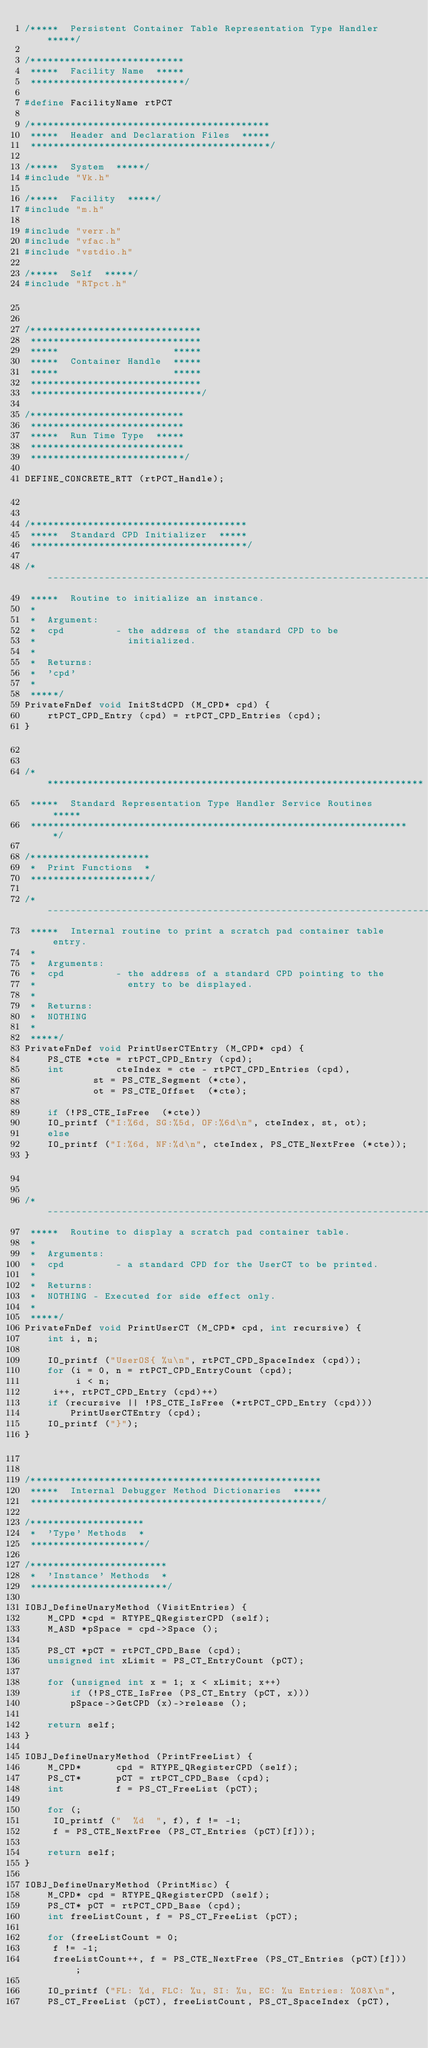<code> <loc_0><loc_0><loc_500><loc_500><_C++_>/*****  Persistent Container Table Representation Type Handler  *****/

/***************************
 *****  Facility Name  *****
 ***************************/

#define FacilityName rtPCT

/******************************************
 *****  Header and Declaration Files  *****
 ******************************************/

/*****  System  *****/
#include "Vk.h"

/*****  Facility  *****/
#include "m.h"

#include "verr.h"
#include "vfac.h"
#include "vstdio.h"

/*****  Self  *****/
#include "RTpct.h"


/******************************
 ******************************
 *****                    *****
 *****  Container Handle  *****
 *****                    *****
 ******************************
 ******************************/

/***************************
 ***************************
 *****  Run Time Type  *****
 ***************************
 ***************************/

DEFINE_CONCRETE_RTT (rtPCT_Handle);


/**************************************
 *****  Standard CPD Initializer  *****
 **************************************/

/*---------------------------------------------------------------------------
 *****  Routine to initialize an instance.
 *
 *  Argument:
 *	cpd			- the address of the standard CPD to be
 *				  initialized.
 *
 *  Returns:
 *	'cpd'
 *
 *****/
PrivateFnDef void InitStdCPD (M_CPD* cpd) {
    rtPCT_CPD_Entry (cpd) = rtPCT_CPD_Entries (cpd);
}


/*******************************************************************
 *****  Standard Representation Type Handler Service Routines  *****
 *******************************************************************/

/*********************
 *  Print Functions  *
 *********************/

/*---------------------------------------------------------------------------
 *****  Internal routine to print a scratch pad container table entry.
 *
 *  Arguments:
 *	cpd			- the address of a standard CPD pointing to the
 *				  entry to be displayed.
 *
 *  Returns:
 *	NOTHING
 *
 *****/
PrivateFnDef void PrintUserCTEntry (M_CPD* cpd) {
    PS_CTE *cte = rtPCT_CPD_Entry (cpd);
    int			cteIndex = cte - rtPCT_CPD_Entries (cpd),
			st = PS_CTE_Segment (*cte),
			ot = PS_CTE_Offset  (*cte);

    if (!PS_CTE_IsFree  (*cte))
	IO_printf ("I:%6d, SG:%5d, OF:%6d\n", cteIndex, st, ot);
    else
	IO_printf ("I:%6d, NF:%d\n", cteIndex, PS_CTE_NextFree (*cte));
}


/*---------------------------------------------------------------------------
 *****  Routine to display a scratch pad container table.
 *
 *  Arguments:
 *	cpd			- a standard CPD for the UserCT to be printed.
 *
 *  Returns:
 *	NOTHING - Executed for side effect only.
 *
 *****/
PrivateFnDef void PrintUserCT (M_CPD* cpd, int recursive) {
    int	i, n;

    IO_printf ("UserOS{ %u\n", rtPCT_CPD_SpaceIndex (cpd));
    for (i = 0, n = rtPCT_CPD_EntryCount (cpd);
    	 i < n;
	 i++, rtPCT_CPD_Entry (cpd)++)
	if (recursive || !PS_CTE_IsFree (*rtPCT_CPD_Entry (cpd)))
	    PrintUserCTEntry (cpd);
    IO_printf ("}");
}


/***************************************************
 *****  Internal Debugger Method Dictionaries  *****
 ***************************************************/

/********************
 *  'Type' Methods  *
 ********************/

/************************
 *  'Instance' Methods  *
 ************************/

IOBJ_DefineUnaryMethod (VisitEntries) {
    M_CPD *cpd = RTYPE_QRegisterCPD (self);
    M_ASD *pSpace = cpd->Space ();

    PS_CT *pCT = rtPCT_CPD_Base (cpd);
    unsigned int xLimit = PS_CT_EntryCount (pCT);

    for (unsigned int x = 1; x < xLimit; x++)
        if (!PS_CTE_IsFree (PS_CT_Entry (pCT, x)))
	    pSpace->GetCPD (x)->release ();

    return self;
}

IOBJ_DefineUnaryMethod (PrintFreeList) {
    M_CPD*		cpd = RTYPE_QRegisterCPD (self);
    PS_CT*		pCT = rtPCT_CPD_Base (cpd);
    int			f = PS_CT_FreeList (pCT);

    for (;
	 IO_printf ("  %d  ", f), f != -1;
	 f = PS_CTE_NextFree (PS_CT_Entries (pCT)[f]));

    return self;
}

IOBJ_DefineUnaryMethod (PrintMisc) {
    M_CPD* cpd = RTYPE_QRegisterCPD (self);
    PS_CT* pCT = rtPCT_CPD_Base (cpd);
    int freeListCount, f = PS_CT_FreeList (pCT);

    for (freeListCount = 0;
	 f != -1;
	 freeListCount++, f = PS_CTE_NextFree (PS_CT_Entries (pCT)[f]));

    IO_printf ("FL: %d, FLC: %u, SI: %u, EC: %u Entries: %08X\n",
	PS_CT_FreeList (pCT), freeListCount, PS_CT_SpaceIndex (pCT),</code> 